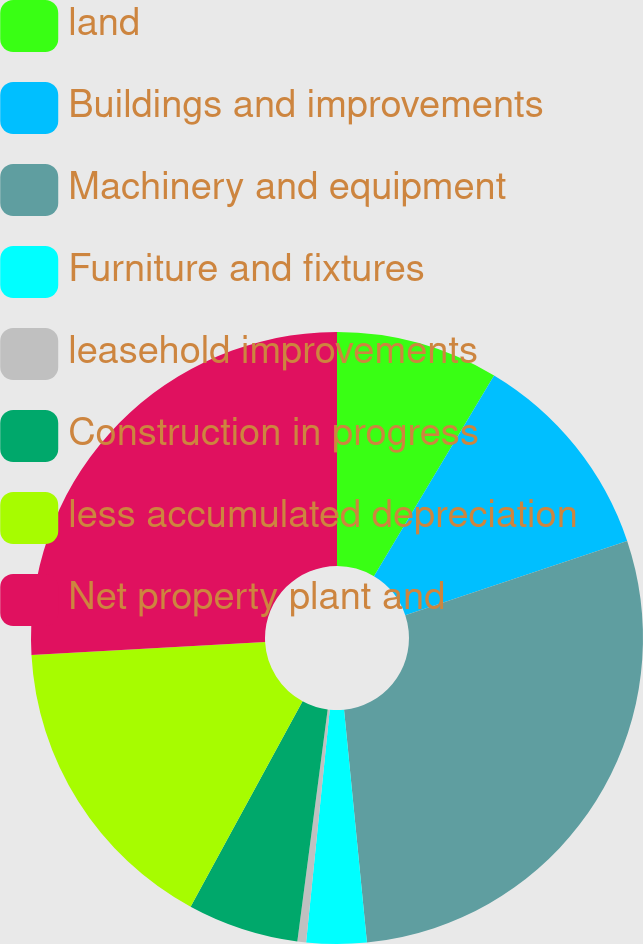<chart> <loc_0><loc_0><loc_500><loc_500><pie_chart><fcel>land<fcel>Buildings and improvements<fcel>Machinery and equipment<fcel>Furniture and fixtures<fcel>leasehold improvements<fcel>Construction in progress<fcel>less accumulated depreciation<fcel>Net property plant and<nl><fcel>8.58%<fcel>11.28%<fcel>28.58%<fcel>3.17%<fcel>0.46%<fcel>5.87%<fcel>16.18%<fcel>25.88%<nl></chart> 